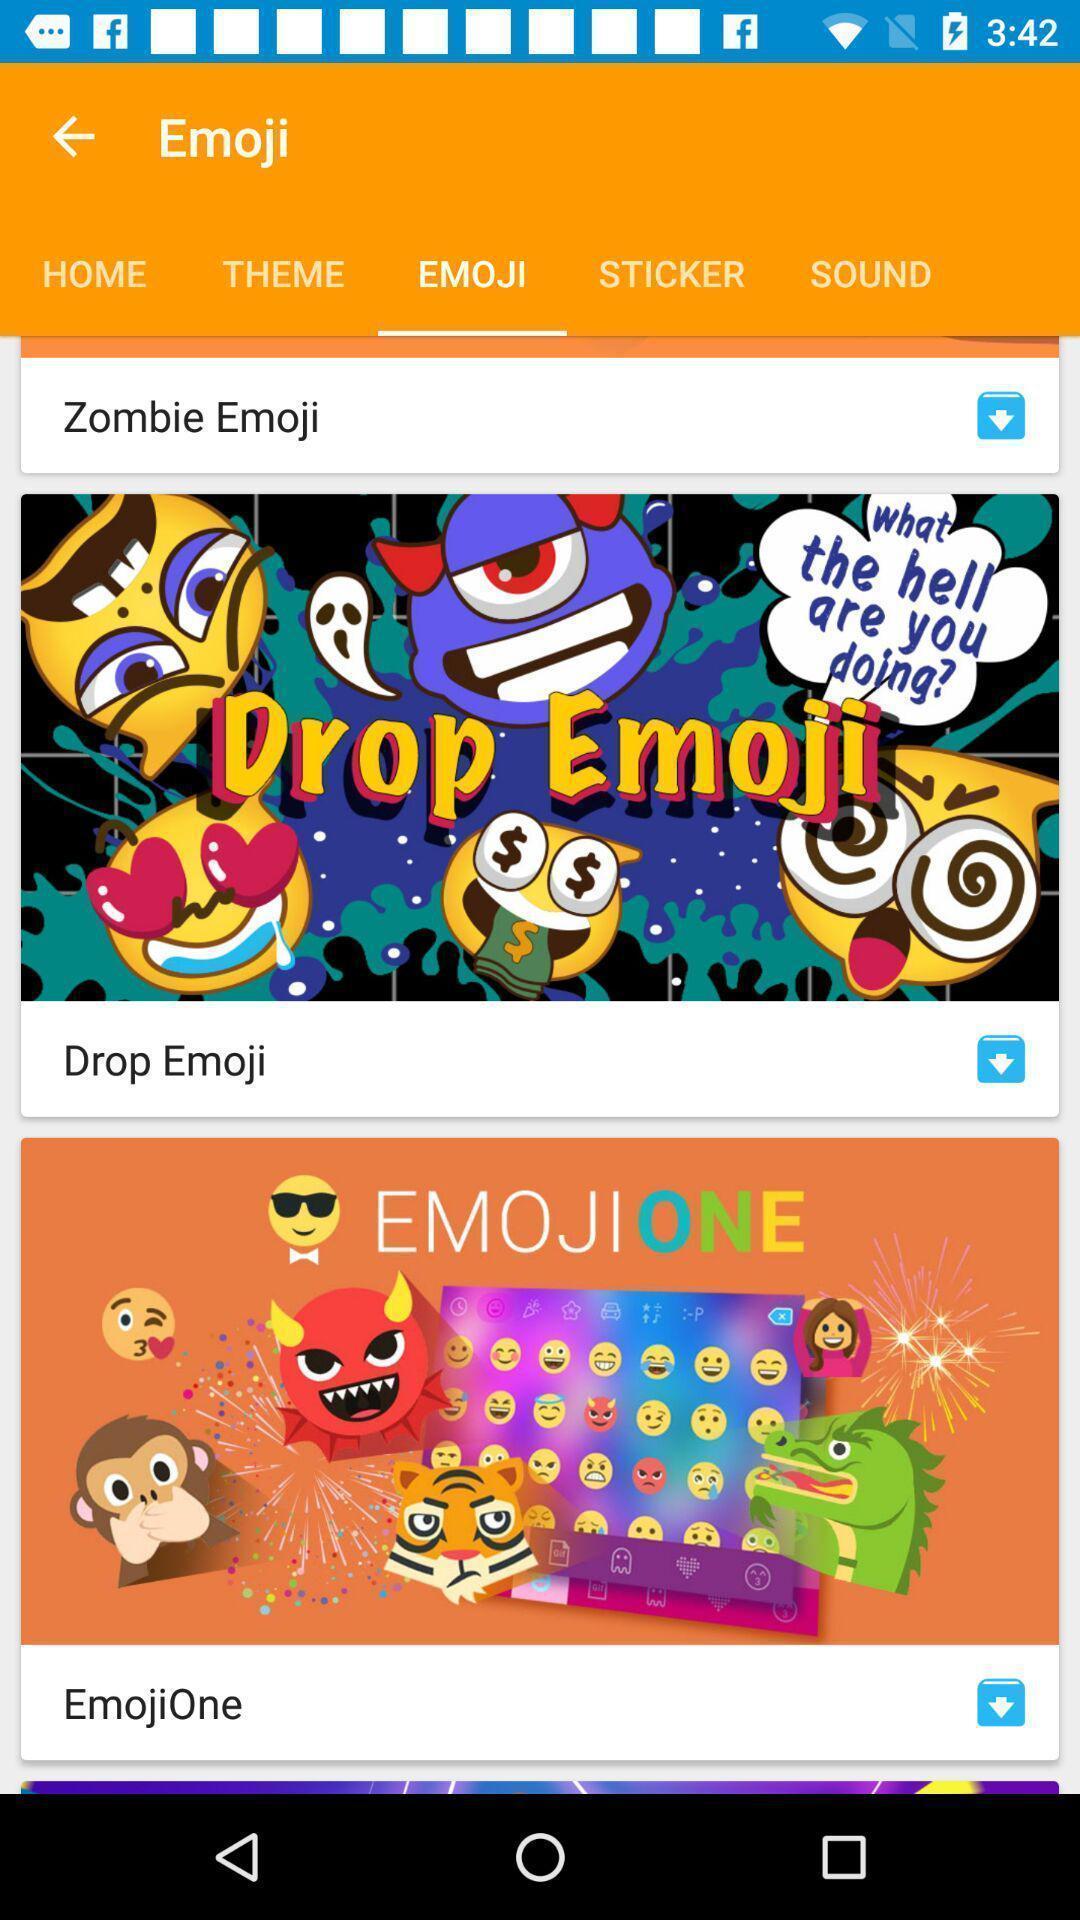Explain what's happening in this screen capture. Screen displaying the emoji page. 